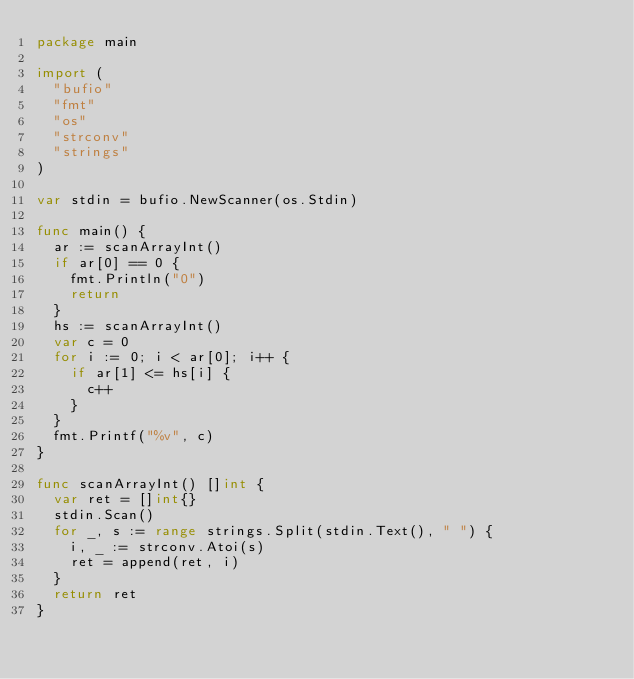<code> <loc_0><loc_0><loc_500><loc_500><_Go_>package main

import (
	"bufio"
	"fmt"
	"os"
	"strconv"
	"strings"
)

var stdin = bufio.NewScanner(os.Stdin)

func main() {
	ar := scanArrayInt()
	if ar[0] == 0 {
		fmt.Println("0")
		return
	}
	hs := scanArrayInt()
	var c = 0
	for i := 0; i < ar[0]; i++ {
		if ar[1] <= hs[i] {
			c++
		}
	}
	fmt.Printf("%v", c)
}

func scanArrayInt() []int {
	var ret = []int{}
	stdin.Scan()
	for _, s := range strings.Split(stdin.Text(), " ") {
		i, _ := strconv.Atoi(s)
		ret = append(ret, i)
	}
	return ret
}
</code> 